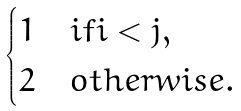Convert formula to latex. <formula><loc_0><loc_0><loc_500><loc_500>\begin{cases} 1 & i f i < j , \\ 2 & o t h e r w i s e . \end{cases}</formula> 